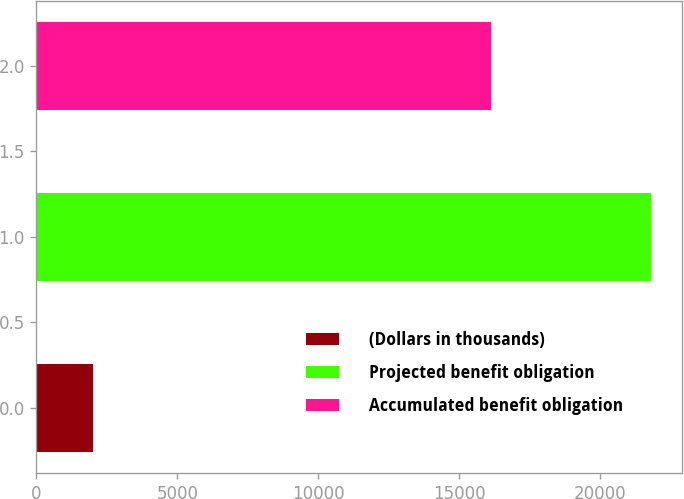Convert chart to OTSL. <chart><loc_0><loc_0><loc_500><loc_500><bar_chart><fcel>(Dollars in thousands)<fcel>Projected benefit obligation<fcel>Accumulated benefit obligation<nl><fcel>2007<fcel>21815<fcel>16130<nl></chart> 